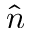<formula> <loc_0><loc_0><loc_500><loc_500>\hat { n }</formula> 